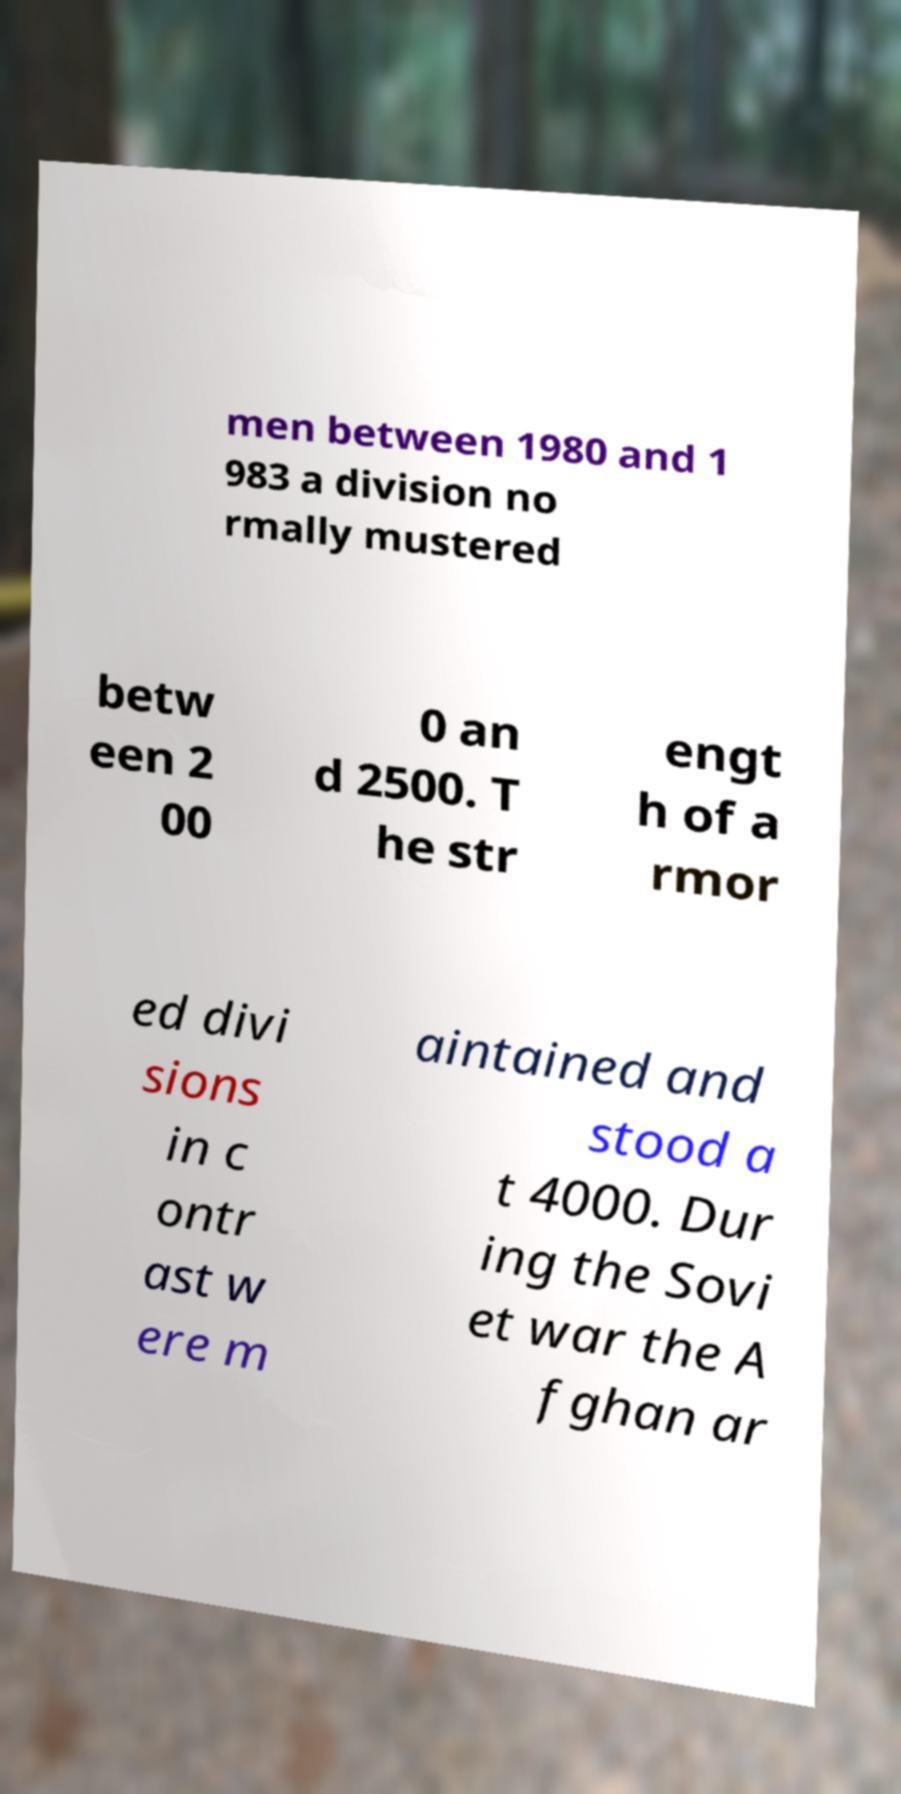Can you accurately transcribe the text from the provided image for me? men between 1980 and 1 983 a division no rmally mustered betw een 2 00 0 an d 2500. T he str engt h of a rmor ed divi sions in c ontr ast w ere m aintained and stood a t 4000. Dur ing the Sovi et war the A fghan ar 